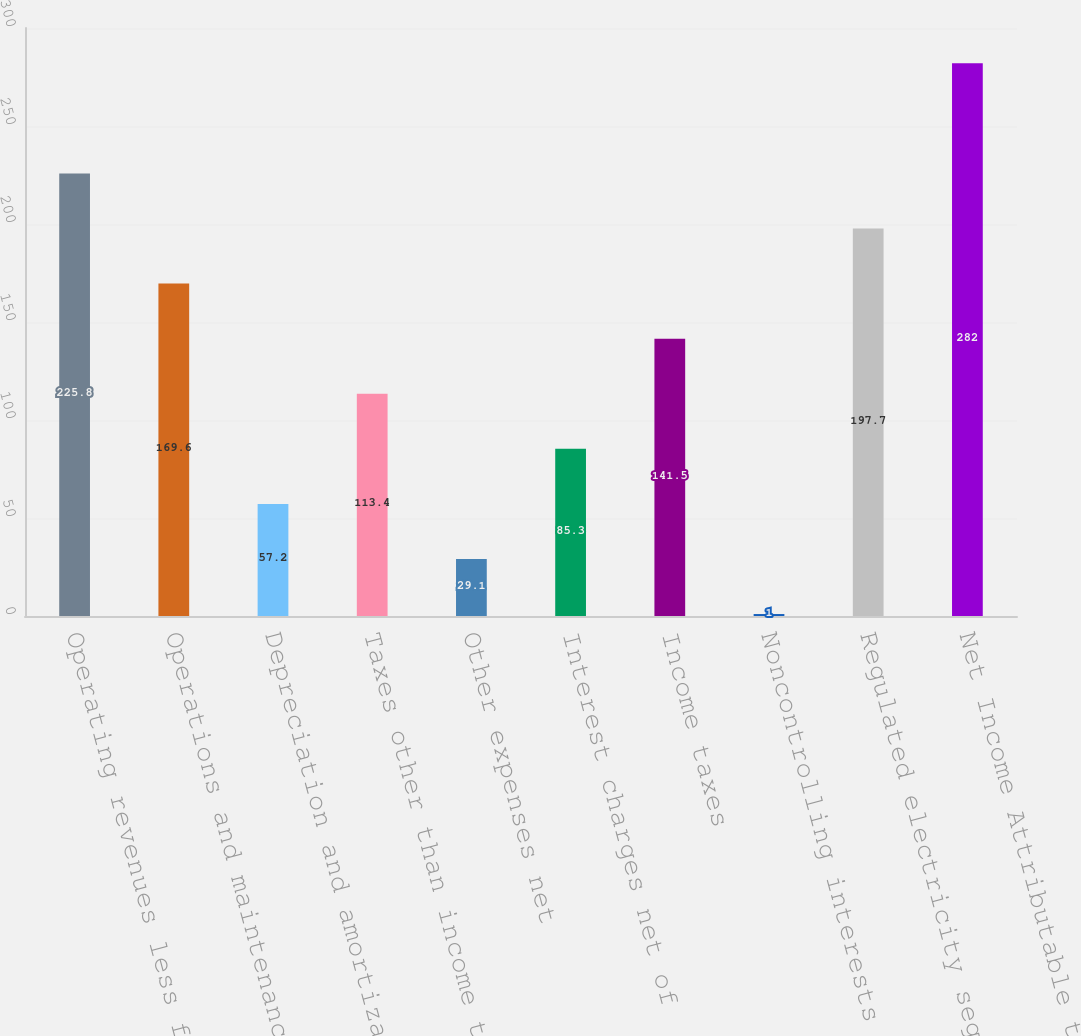Convert chart. <chart><loc_0><loc_0><loc_500><loc_500><bar_chart><fcel>Operating revenues less fuel<fcel>Operations and maintenance (a)<fcel>Depreciation and amortization<fcel>Taxes other than income taxes<fcel>Other expenses net<fcel>Interest charges net of<fcel>Income taxes<fcel>Noncontrolling interests (Note<fcel>Regulated electricity segment<fcel>Net Income Attributable to<nl><fcel>225.8<fcel>169.6<fcel>57.2<fcel>113.4<fcel>29.1<fcel>85.3<fcel>141.5<fcel>1<fcel>197.7<fcel>282<nl></chart> 